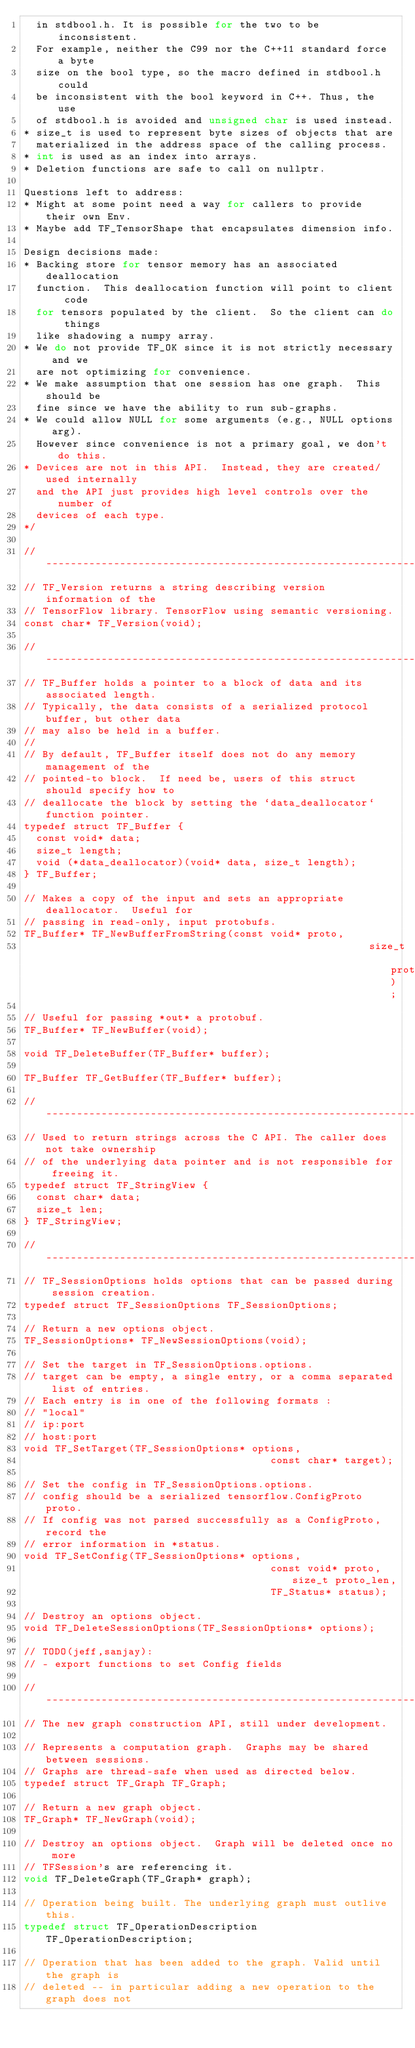<code> <loc_0><loc_0><loc_500><loc_500><_C_>  in stdbool.h. It is possible for the two to be inconsistent.
  For example, neither the C99 nor the C++11 standard force a byte
  size on the bool type, so the macro defined in stdbool.h could
  be inconsistent with the bool keyword in C++. Thus, the use
  of stdbool.h is avoided and unsigned char is used instead.
* size_t is used to represent byte sizes of objects that are
  materialized in the address space of the calling process.
* int is used as an index into arrays.
* Deletion functions are safe to call on nullptr.

Questions left to address:
* Might at some point need a way for callers to provide their own Env.
* Maybe add TF_TensorShape that encapsulates dimension info.

Design decisions made:
* Backing store for tensor memory has an associated deallocation
  function.  This deallocation function will point to client code
  for tensors populated by the client.  So the client can do things
  like shadowing a numpy array.
* We do not provide TF_OK since it is not strictly necessary and we
  are not optimizing for convenience.
* We make assumption that one session has one graph.  This should be
  fine since we have the ability to run sub-graphs.
* We could allow NULL for some arguments (e.g., NULL options arg).
  However since convenience is not a primary goal, we don't do this.
* Devices are not in this API.  Instead, they are created/used internally
  and the API just provides high level controls over the number of
  devices of each type.
*/

// --------------------------------------------------------------------------
// TF_Version returns a string describing version information of the
// TensorFlow library. TensorFlow using semantic versioning.
const char* TF_Version(void);

// --------------------------------------------------------------------------
// TF_Buffer holds a pointer to a block of data and its associated length.
// Typically, the data consists of a serialized protocol buffer, but other data
// may also be held in a buffer.
//
// By default, TF_Buffer itself does not do any memory management of the
// pointed-to block.  If need be, users of this struct should specify how to
// deallocate the block by setting the `data_deallocator` function pointer.
typedef struct TF_Buffer {
  const void* data;
  size_t length;
  void (*data_deallocator)(void* data, size_t length);
} TF_Buffer;

// Makes a copy of the input and sets an appropriate deallocator.  Useful for
// passing in read-only, input protobufs.
TF_Buffer* TF_NewBufferFromString(const void* proto,
                                                        size_t proto_len);

// Useful for passing *out* a protobuf.
TF_Buffer* TF_NewBuffer(void);

void TF_DeleteBuffer(TF_Buffer* buffer);

TF_Buffer TF_GetBuffer(TF_Buffer* buffer);

// --------------------------------------------------------------------------
// Used to return strings across the C API. The caller does not take ownership
// of the underlying data pointer and is not responsible for freeing it.
typedef struct TF_StringView {
  const char* data;
  size_t len;
} TF_StringView;

// --------------------------------------------------------------------------
// TF_SessionOptions holds options that can be passed during session creation.
typedef struct TF_SessionOptions TF_SessionOptions;

// Return a new options object.
TF_SessionOptions* TF_NewSessionOptions(void);

// Set the target in TF_SessionOptions.options.
// target can be empty, a single entry, or a comma separated list of entries.
// Each entry is in one of the following formats :
// "local"
// ip:port
// host:port
void TF_SetTarget(TF_SessionOptions* options,
                                        const char* target);

// Set the config in TF_SessionOptions.options.
// config should be a serialized tensorflow.ConfigProto proto.
// If config was not parsed successfully as a ConfigProto, record the
// error information in *status.
void TF_SetConfig(TF_SessionOptions* options,
                                        const void* proto, size_t proto_len,
                                        TF_Status* status);

// Destroy an options object.
void TF_DeleteSessionOptions(TF_SessionOptions* options);

// TODO(jeff,sanjay):
// - export functions to set Config fields

// --------------------------------------------------------------------------
// The new graph construction API, still under development.

// Represents a computation graph.  Graphs may be shared between sessions.
// Graphs are thread-safe when used as directed below.
typedef struct TF_Graph TF_Graph;

// Return a new graph object.
TF_Graph* TF_NewGraph(void);

// Destroy an options object.  Graph will be deleted once no more
// TFSession's are referencing it.
void TF_DeleteGraph(TF_Graph* graph);

// Operation being built. The underlying graph must outlive this.
typedef struct TF_OperationDescription TF_OperationDescription;

// Operation that has been added to the graph. Valid until the graph is
// deleted -- in particular adding a new operation to the graph does not</code> 